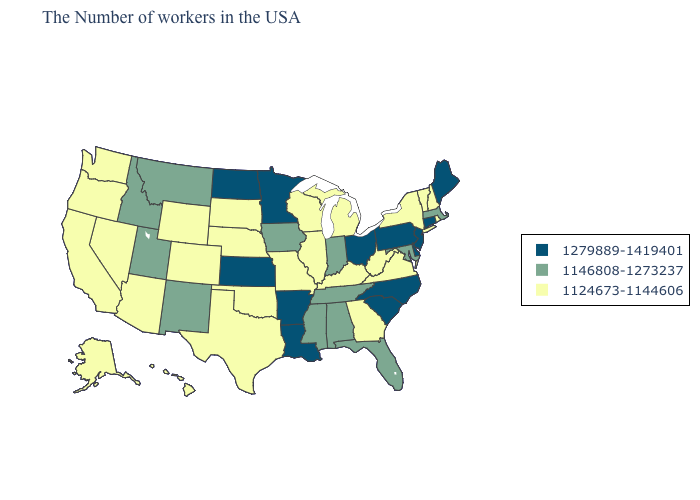What is the value of Maryland?
Quick response, please. 1146808-1273237. What is the value of Oregon?
Be succinct. 1124673-1144606. Name the states that have a value in the range 1124673-1144606?
Keep it brief. Rhode Island, New Hampshire, Vermont, New York, Virginia, West Virginia, Georgia, Michigan, Kentucky, Wisconsin, Illinois, Missouri, Nebraska, Oklahoma, Texas, South Dakota, Wyoming, Colorado, Arizona, Nevada, California, Washington, Oregon, Alaska, Hawaii. Does Rhode Island have the highest value in the Northeast?
Quick response, please. No. What is the lowest value in states that border Washington?
Quick response, please. 1124673-1144606. What is the value of West Virginia?
Be succinct. 1124673-1144606. Which states have the lowest value in the USA?
Short answer required. Rhode Island, New Hampshire, Vermont, New York, Virginia, West Virginia, Georgia, Michigan, Kentucky, Wisconsin, Illinois, Missouri, Nebraska, Oklahoma, Texas, South Dakota, Wyoming, Colorado, Arizona, Nevada, California, Washington, Oregon, Alaska, Hawaii. Does Missouri have the lowest value in the MidWest?
Concise answer only. Yes. What is the value of Nebraska?
Concise answer only. 1124673-1144606. What is the lowest value in the USA?
Short answer required. 1124673-1144606. What is the value of Louisiana?
Quick response, please. 1279889-1419401. Name the states that have a value in the range 1146808-1273237?
Keep it brief. Massachusetts, Maryland, Florida, Indiana, Alabama, Tennessee, Mississippi, Iowa, New Mexico, Utah, Montana, Idaho. Is the legend a continuous bar?
Short answer required. No. What is the highest value in the South ?
Answer briefly. 1279889-1419401. 